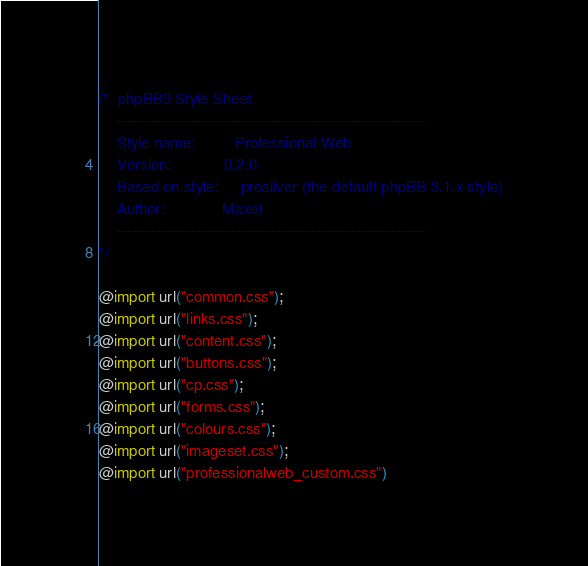Convert code to text. <code><loc_0><loc_0><loc_500><loc_500><_CSS_>/*  phpBB3 Style Sheet
    --------------------------------------------------------------
	Style name:			Professional Web
	Version: 			0.2.0 
	Based on style:		prosilver (the default phpBB 3.1.x style)
	Author:				Maxel
    --------------------------------------------------------------
*/

@import url("common.css");
@import url("links.css");
@import url("content.css");
@import url("buttons.css");
@import url("cp.css");
@import url("forms.css");
@import url("colours.css");
@import url("imageset.css");
@import url("professionalweb_custom.css")
</code> 